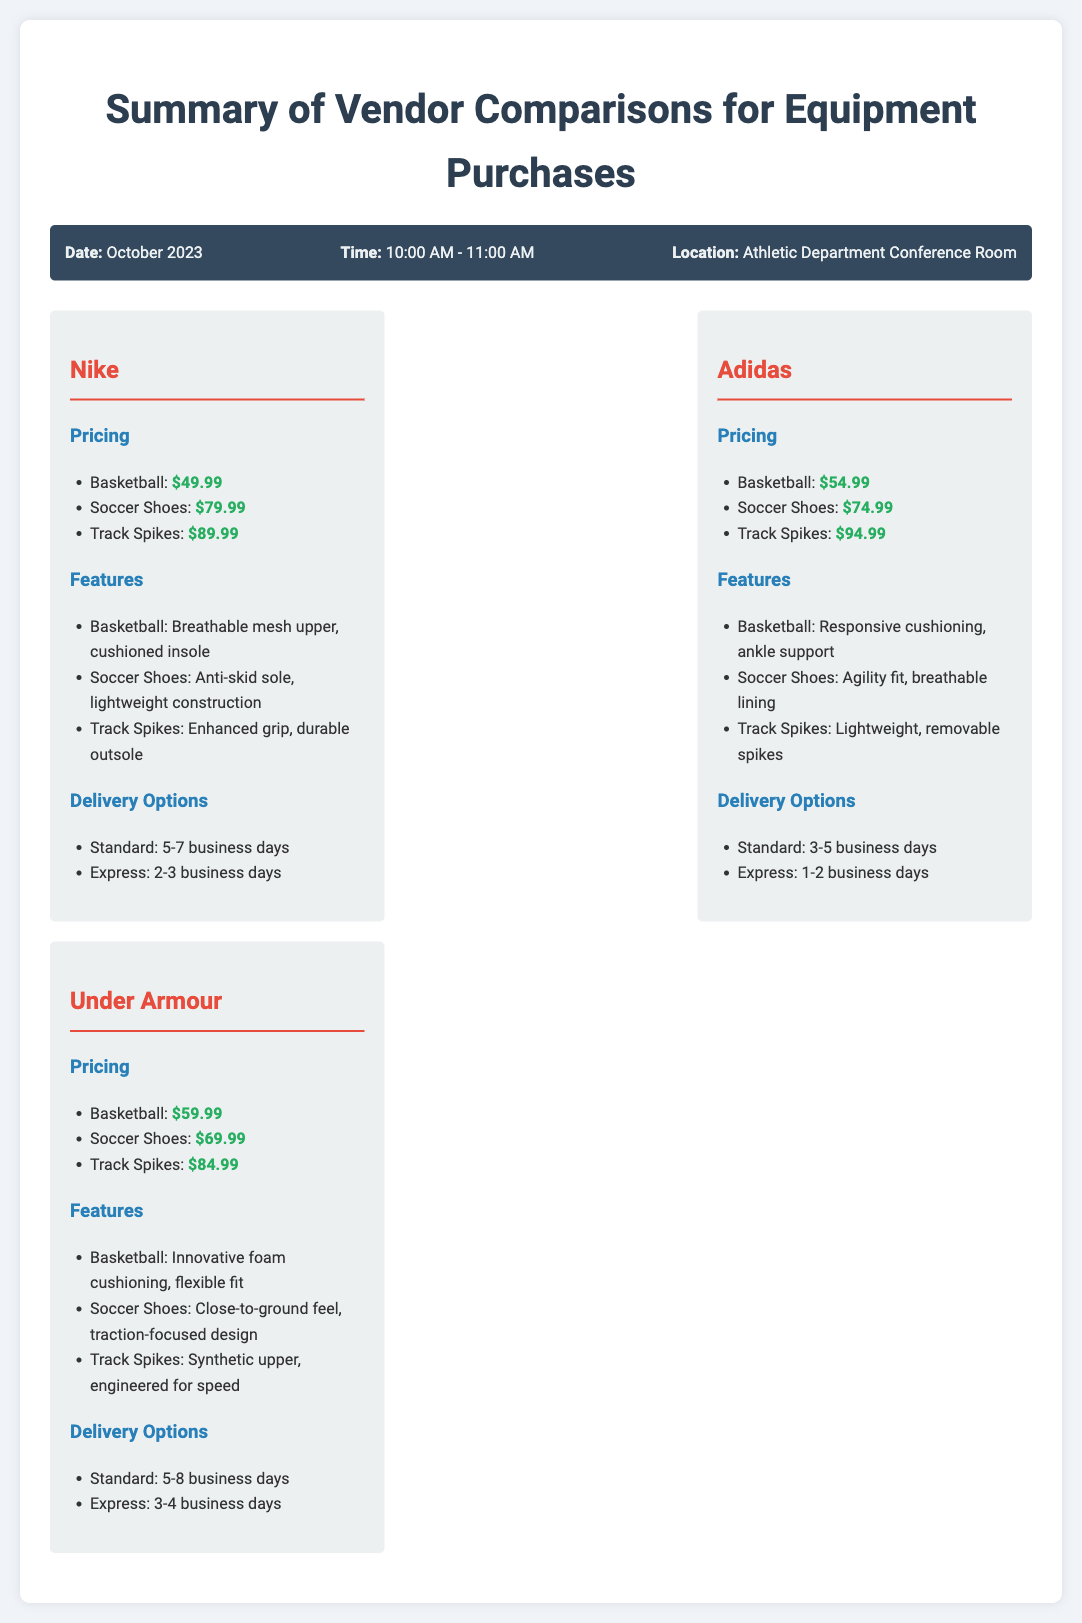What is the price of Basketball from Nike? The price listed for Basketball from Nike is $49.99.
Answer: $49.99 What is the delivery time for Adidas' Express option? The Express delivery option for Adidas takes 1-2 business days.
Answer: 1-2 business days Which vendor offers the lowest price for Soccer Shoes? By comparing the prices, Under Armour offers the lowest price for Soccer Shoes at $69.99.
Answer: Under Armour What feature is associated with Adidas Track Spikes? The feature associated with Adidas Track Spikes is "lightweight, removable spikes."
Answer: lightweight, removable spikes What is the date of the vendor comparison meeting? The date of the vendor comparison meeting is mentioned in the header info.
Answer: October 2023 Which vendor has Standard delivery time between 5 to 7 business days? Nike's Standard delivery option is specified to take 5-7 business days.
Answer: Nike What feature is unique to Under Armour Basketball shoes? Under Armour Basketball shoes have "innovative foam cushioning, flexible fit" as a unique feature.
Answer: innovative foam cushioning, flexible fit How many vendors are compared in the document? The document compares three vendors.
Answer: three vendors What is the title of the document? The title is stated prominently at the top.
Answer: Summary of Vendor Comparisons for Equipment Purchases 